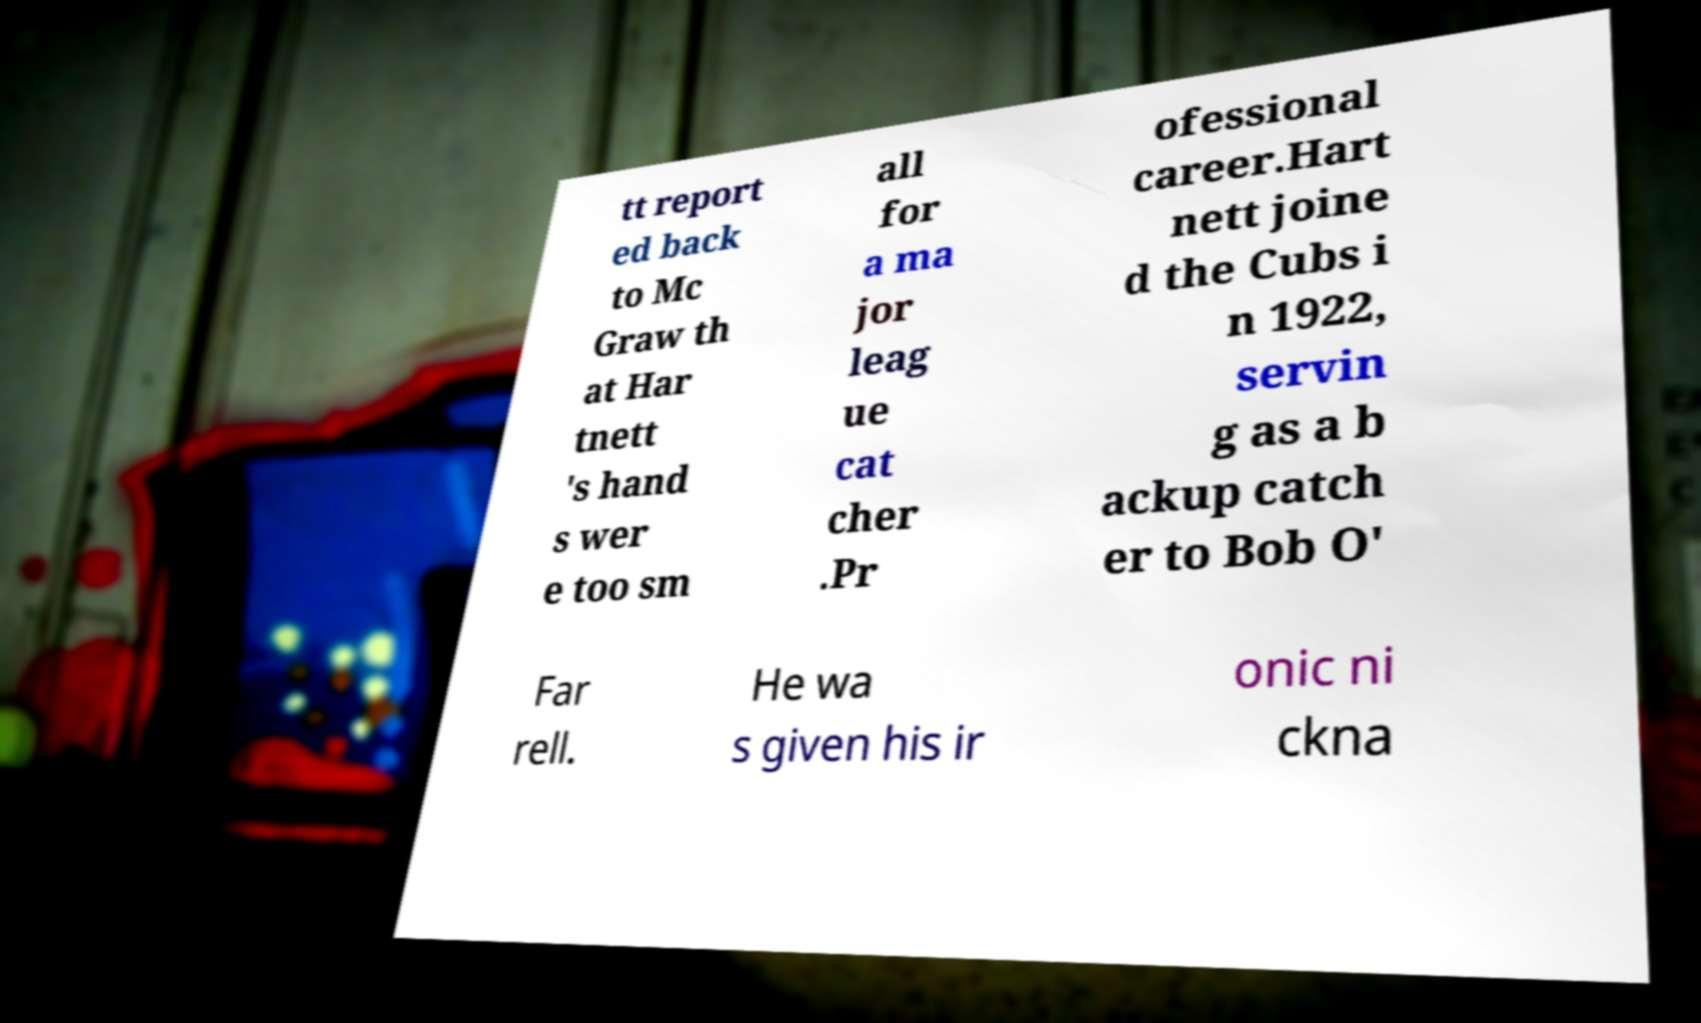Can you accurately transcribe the text from the provided image for me? tt report ed back to Mc Graw th at Har tnett 's hand s wer e too sm all for a ma jor leag ue cat cher .Pr ofessional career.Hart nett joine d the Cubs i n 1922, servin g as a b ackup catch er to Bob O' Far rell. He wa s given his ir onic ni ckna 